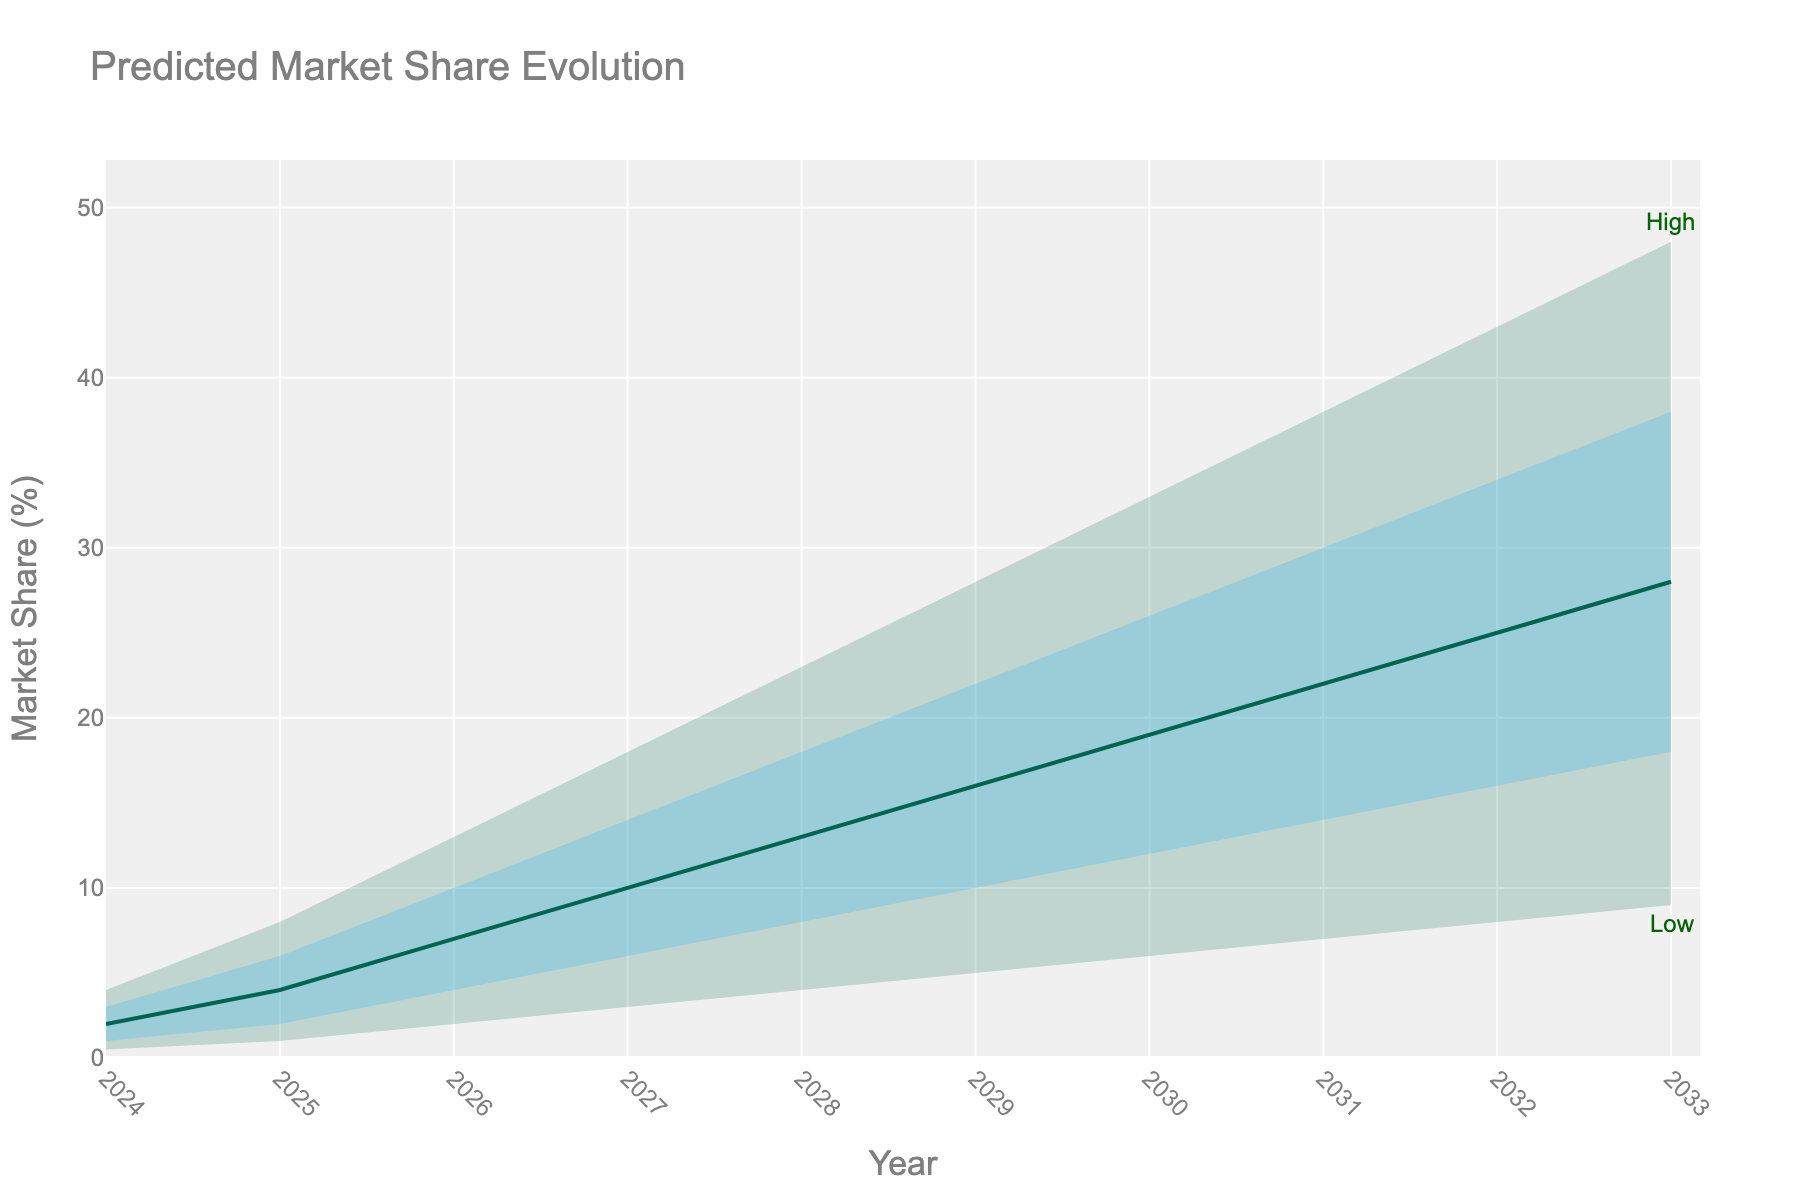what is the title of the chart? The chart's title is located at the top center and typically summarizes the content of the chart.
Answer: Predicted Market Share Evolution what does the y-axis represent? The y-axis usually labels the variable being measured. Here, it shows the percentage of market share.
Answer: Market Share (%) what are the colors used for the different fan segments in the chart? The chart uses different colors to visually distinguish between segments. Here, the lighter color (light green) is used for the 'Low' values, a medium shade (light blue) for 'Low-Mid' to 'Mid-High,' and a darker green for the 'Mid' values.
Answer: Light green, light blue, dark green what's the predicted market share range in 2027 (low to high)? For 2027, find the corresponding values for the ‘Low’ and ‘High’ predictions on the y-axis. According to the data, 'Low' is 3% and 'High' is 18%.
Answer: 3% to 18% what is the predicted ‘Mid’ market share in 2030? Locate the year 2030 and check the value for the ‘Mid’ prediction. According to the data, the value is 19%.
Answer: 19% compare the predicted high market share between 2025 and 2032. Which year has a higher value? First, locate the 'High' values for 2025 and 2032. For 2025, it’s 8%, and for 2032, it’s 43%. Comparing these, the value in 2032 is higher.
Answer: 2032 what is the total range of predicted market share evolution for 2029 (difference between high and low)? To find the range, subtract the 'Low' value from the 'High' value for 2029: 28% - 5% = 23%.
Answer: 23% what does the shaded area between the high (upper bound) and low (lower bound) lines indicate? The shaded area shows the uncertainty or the range within which the market share is predicted to lie. The broader the shaded area, the higher the uncertainty.
Answer: Prediction uncertainty range how does the predicted market share trend over the 10 years? Observe the 'Mid' line from 2024 to 2033. There is a rising trend throughout the period, indicating expected growth in market share over the years.
Answer: Rising trend what was the first year the predicted mid-market share exceeded 10%? Locate the 'Mid' values over the years and observe when it first crosses 10%. It first exceeds 10% in 2027.
Answer: 2027 